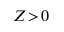<formula> <loc_0><loc_0><loc_500><loc_500>Z \, > \, 0</formula> 